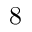<formula> <loc_0><loc_0><loc_500><loc_500>8</formula> 